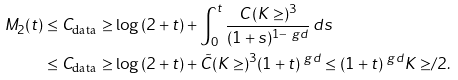Convert formula to latex. <formula><loc_0><loc_0><loc_500><loc_500>M _ { 2 } ( t ) & \leq C _ { \text {data} } \geq \log { ( 2 + t ) } + \int _ { 0 } ^ { t } \frac { C \, ( K \geq ) ^ { 3 } } { ( 1 + s ) ^ { 1 - \ g d } } \, d s \\ & \leq C _ { \text {data} } \geq \log { ( 2 + t ) } + \tilde { C } ( K \geq ) ^ { 3 } ( 1 + t ) ^ { \ g d } \leq ( 1 + t ) ^ { \ g d } { K \geq } / { 2 } .</formula> 